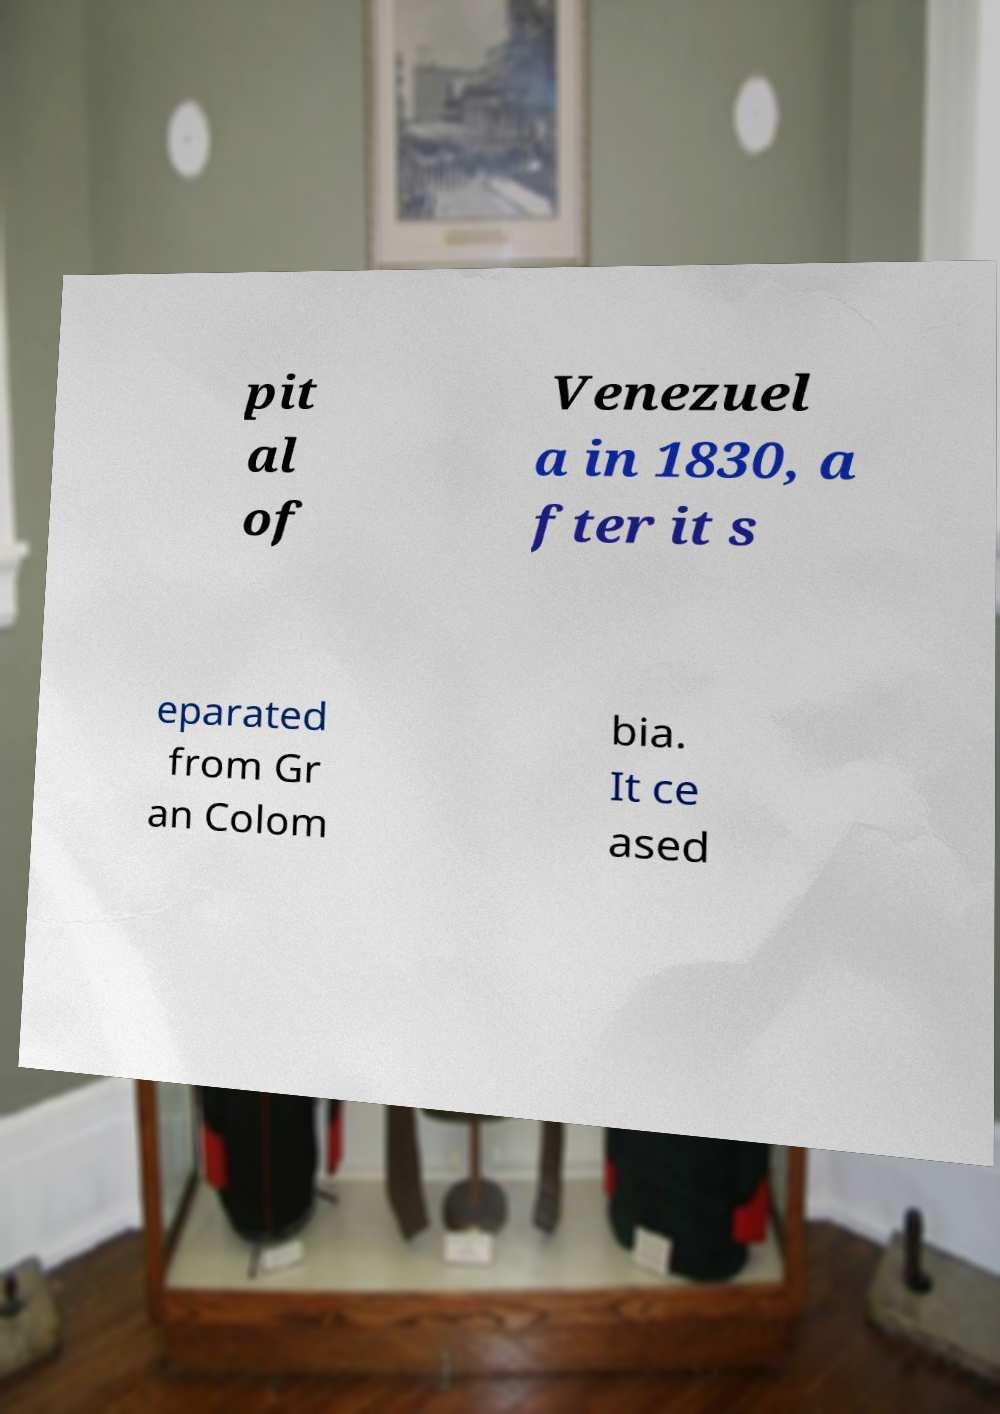I need the written content from this picture converted into text. Can you do that? pit al of Venezuel a in 1830, a fter it s eparated from Gr an Colom bia. It ce ased 